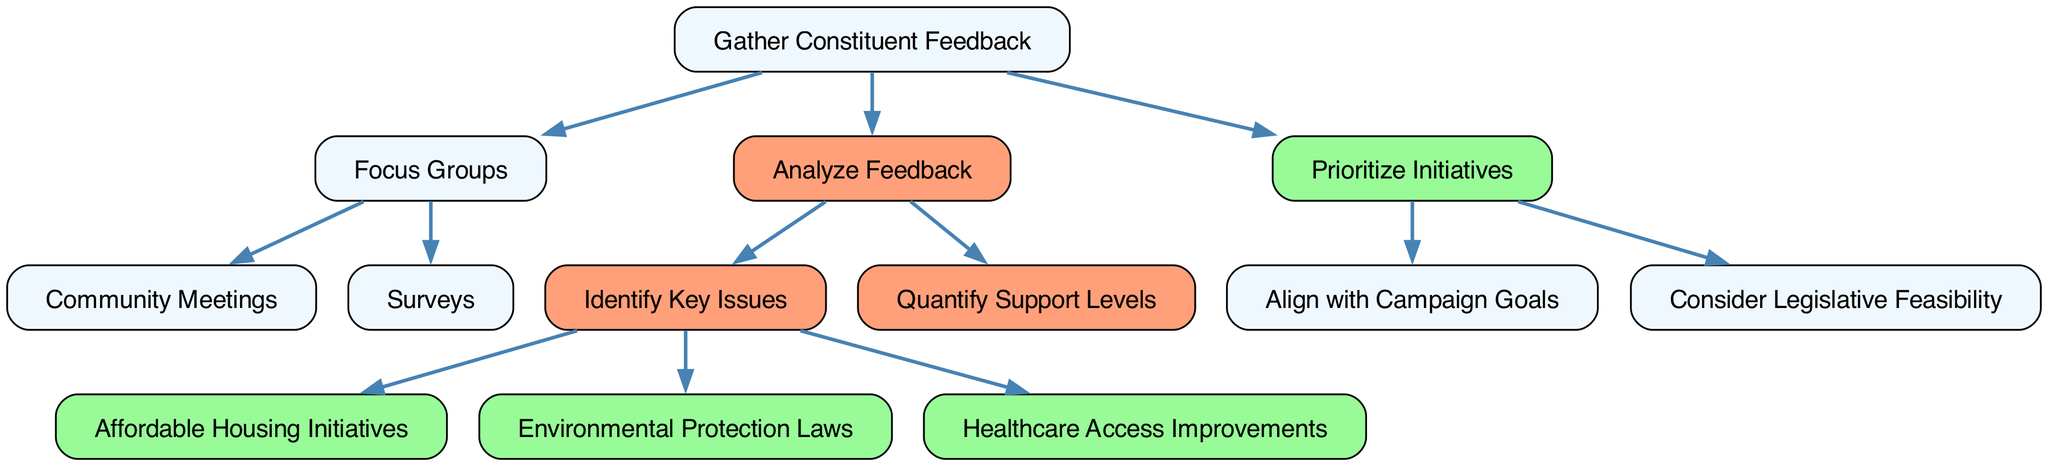What is the root node of this decision tree? The root node is labeled "Gather Constituent Feedback," which indicates it is the starting point for the decisions in this tree.
Answer: Gather Constituent Feedback How many main branches does the decision tree have? The tree has three main branches stemming from the root node: "Focus Groups," "Analyze Feedback," and "Prioritize Initiatives." This can be determined by counting the children connected to the root node.
Answer: Three What are the two types of methods under "Focus Groups"? The two methods are "Community Meetings" and "Surveys," which are both listed as children of the "Focus Groups" node in the diagram.
Answer: Community Meetings and Surveys Which initiative is related to "Identify Key Issues"? The initiatives related to "Identify Key Issues" include "Affordable Housing Initiatives," "Environmental Protection Laws," and "Healthcare Access Improvements." This is found by looking at the children of the "Identify Key Issues" node.
Answer: Affordable Housing Initiatives, Environmental Protection Laws, and Healthcare Access Improvements What does the "Analyze Feedback" node lead to directly? The "Analyze Feedback" node leads directly to "Identify Key Issues" and "Quantify Support Levels," as these are its immediate children in the decision tree.
Answer: Identify Key Issues and Quantify Support Levels What is the last step before initiating legislative initiatives? The last step before initiating legislative initiatives is "Prioritize Initiatives," as this node comes after gathering feedback and analyzing it.
Answer: Prioritize Initiatives How many legislative initiatives are listed? There are three legislative initiatives listed under the "Identify Key Issues" node. This information is easily counted based on the children of the "Identify Key Issues" node.
Answer: Three What approach does the "Prioritize Initiatives" node encourage? The "Prioritize Initiatives" node encourages approaches such as "Align with Campaign Goals" and "Consider Legislative Feasibility," which are its children, indicating the considerations for prioritization.
Answer: Align with Campaign Goals and Consider Legislative Feasibility 